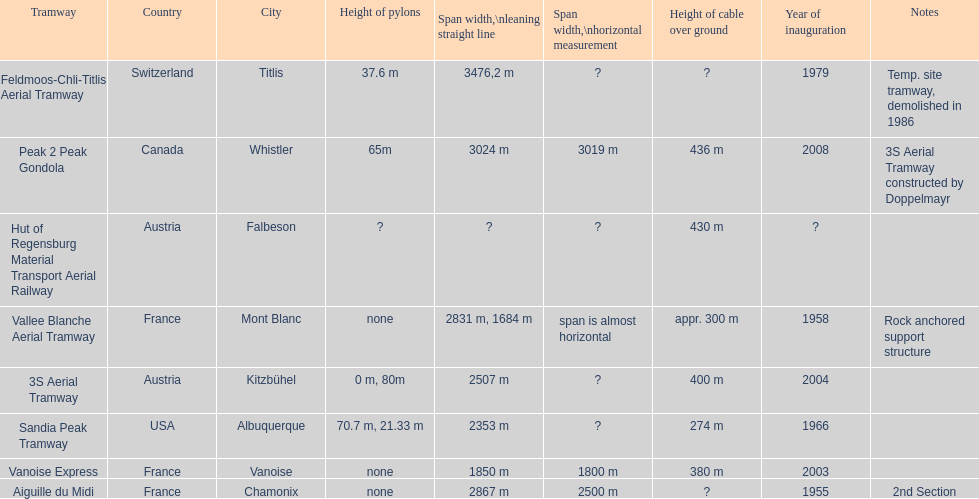Which tramway was built directly before the 3s aeriral tramway? Vanoise Express. 